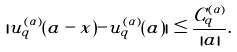Convert formula to latex. <formula><loc_0><loc_0><loc_500><loc_500>| u ^ { ( \alpha ) } _ { q } ( a - x ) - u ^ { ( \alpha ) } _ { q } ( a ) | \leq \frac { C ^ { ( \alpha ) } _ { q } } { | a | } .</formula> 